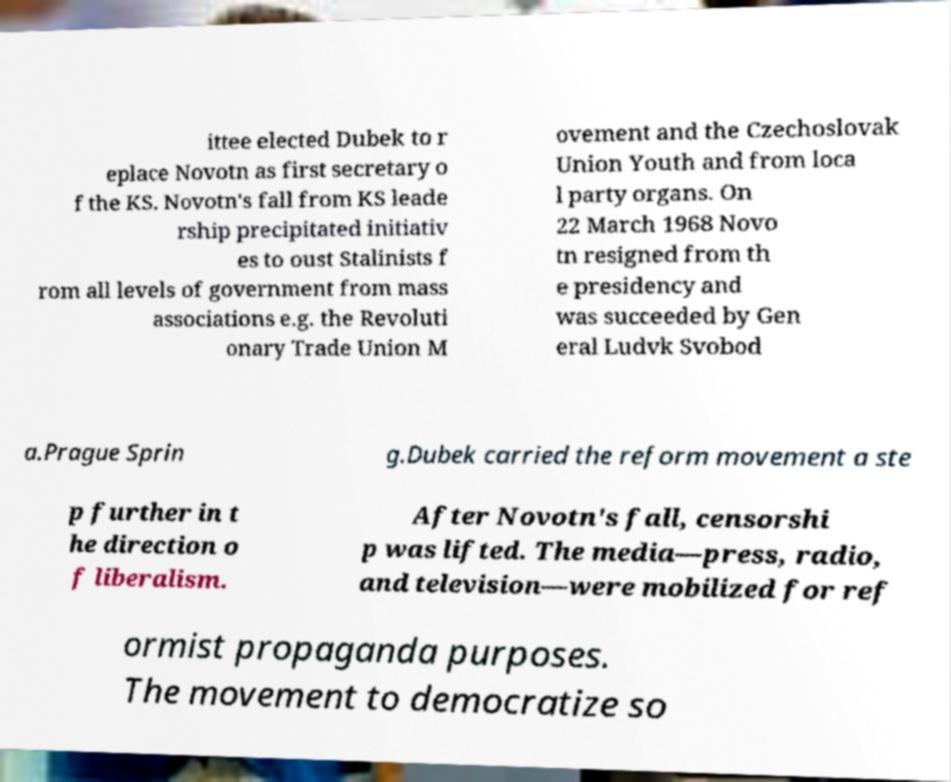What messages or text are displayed in this image? I need them in a readable, typed format. ittee elected Dubek to r eplace Novotn as first secretary o f the KS. Novotn's fall from KS leade rship precipitated initiativ es to oust Stalinists f rom all levels of government from mass associations e.g. the Revoluti onary Trade Union M ovement and the Czechoslovak Union Youth and from loca l party organs. On 22 March 1968 Novo tn resigned from th e presidency and was succeeded by Gen eral Ludvk Svobod a.Prague Sprin g.Dubek carried the reform movement a ste p further in t he direction o f liberalism. After Novotn's fall, censorshi p was lifted. The media—press, radio, and television—were mobilized for ref ormist propaganda purposes. The movement to democratize so 